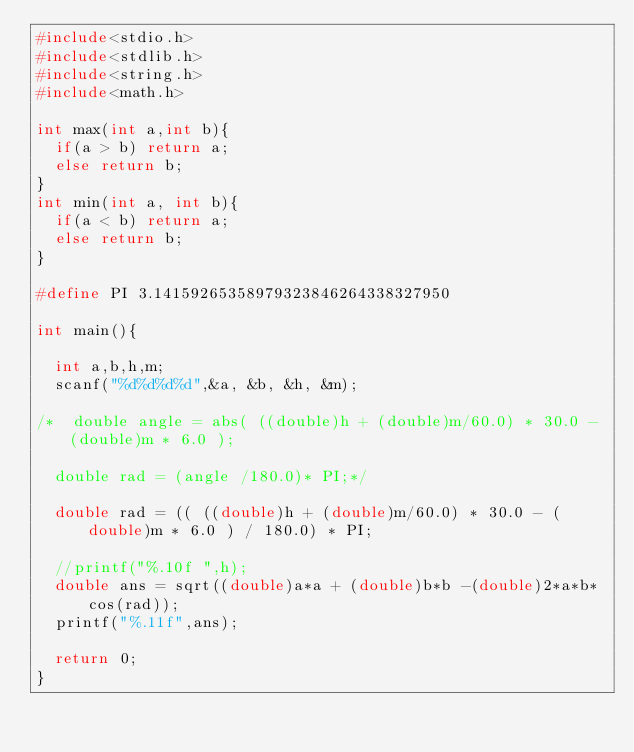<code> <loc_0><loc_0><loc_500><loc_500><_C_>#include<stdio.h>
#include<stdlib.h>
#include<string.h>
#include<math.h>

int max(int a,int b){
  if(a > b) return a;
  else return b;
}
int min(int a, int b){
  if(a < b) return a;
  else return b;
}

#define PI 3.14159265358979323846264338327950

int main(){

  int a,b,h,m;
  scanf("%d%d%d%d",&a, &b, &h, &m);

/*  double angle = abs( ((double)h + (double)m/60.0) * 30.0 - (double)m * 6.0 );

  double rad = (angle /180.0)* PI;*/

  double rad = (( ((double)h + (double)m/60.0) * 30.0 - (double)m * 6.0 ) / 180.0) * PI;

  //printf("%.10f ",h);
  double ans = sqrt((double)a*a + (double)b*b -(double)2*a*b*cos(rad));
  printf("%.11f",ans);

  return 0;
}
</code> 